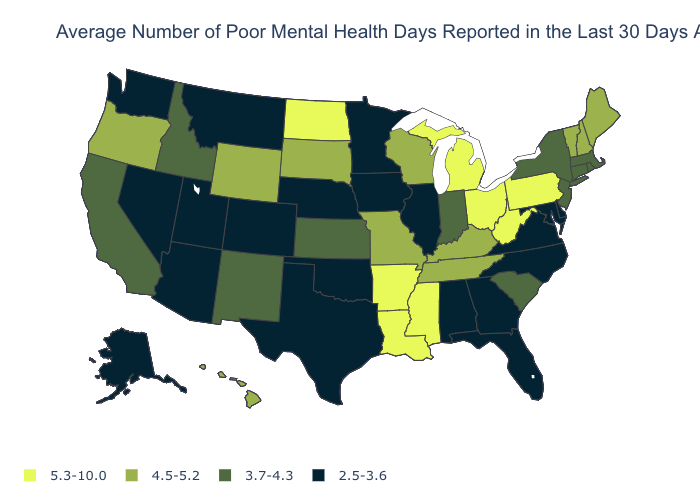Name the states that have a value in the range 4.5-5.2?
Give a very brief answer. Hawaii, Kentucky, Maine, Missouri, New Hampshire, Oregon, South Dakota, Tennessee, Vermont, Wisconsin, Wyoming. Is the legend a continuous bar?
Give a very brief answer. No. Does Washington have a lower value than Alaska?
Answer briefly. No. Name the states that have a value in the range 2.5-3.6?
Be succinct. Alabama, Alaska, Arizona, Colorado, Delaware, Florida, Georgia, Illinois, Iowa, Maryland, Minnesota, Montana, Nebraska, Nevada, North Carolina, Oklahoma, Texas, Utah, Virginia, Washington. Is the legend a continuous bar?
Quick response, please. No. What is the value of Washington?
Short answer required. 2.5-3.6. Name the states that have a value in the range 4.5-5.2?
Short answer required. Hawaii, Kentucky, Maine, Missouri, New Hampshire, Oregon, South Dakota, Tennessee, Vermont, Wisconsin, Wyoming. Does Washington have a lower value than Alabama?
Concise answer only. No. Does Delaware have the lowest value in the USA?
Quick response, please. Yes. Name the states that have a value in the range 4.5-5.2?
Short answer required. Hawaii, Kentucky, Maine, Missouri, New Hampshire, Oregon, South Dakota, Tennessee, Vermont, Wisconsin, Wyoming. Among the states that border Iowa , which have the lowest value?
Concise answer only. Illinois, Minnesota, Nebraska. What is the value of Iowa?
Short answer required. 2.5-3.6. Name the states that have a value in the range 3.7-4.3?
Quick response, please. California, Connecticut, Idaho, Indiana, Kansas, Massachusetts, New Jersey, New Mexico, New York, Rhode Island, South Carolina. Does Washington have the highest value in the USA?
Concise answer only. No. 